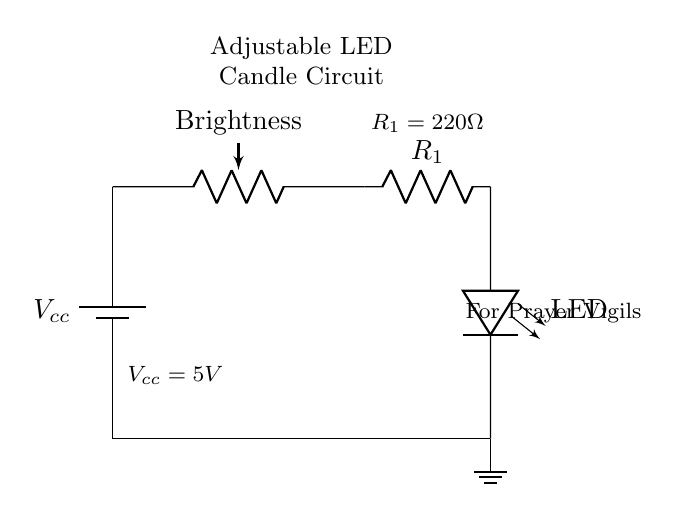What is the power supply voltage? The power supply is marked as Vcc, which has a specified value of 5V in the annotations of the circuit.
Answer: 5V What does the potentiometer control? The potentiometer is labeled as "Brightness" in the circuit, indicating that it adjusts the brightness of the LED by changing the resistance in the circuit.
Answer: Brightness What type of LED is used in this circuit? The circuit diagram uses a generic LED symbol, but it does not specify a type; the component is simply labeled as LED, indicating it is a light-emitting diode.
Answer: LED What is the resistance value of R1? The resistor labeled R1 in the circuit has a specified value of 220 ohms in the annotations, indicating its resistance.
Answer: 220 ohms How is the LED connected in the circuit? The LED is connected in series between the resistor R1 and ground. It is positioned below the resistor and connected directly to the ground, allowing current to pass through in a single path.
Answer: In series What is the function of the potentiometer in this circuit? The potentiometer alters the current flowing through the LED, thus regulating its brightness by varying the resistance in the circuit. As the resistance changes, the current changes, affecting the brightness of the LED.
Answer: Adjusts brightness Is there a ground connection in the circuit? Yes, the circuit diagram includes a ground symbol at the bottom, which denotes the ground connection at 0 volts, completing the circuit by providing a reference point for all voltages.
Answer: Yes 